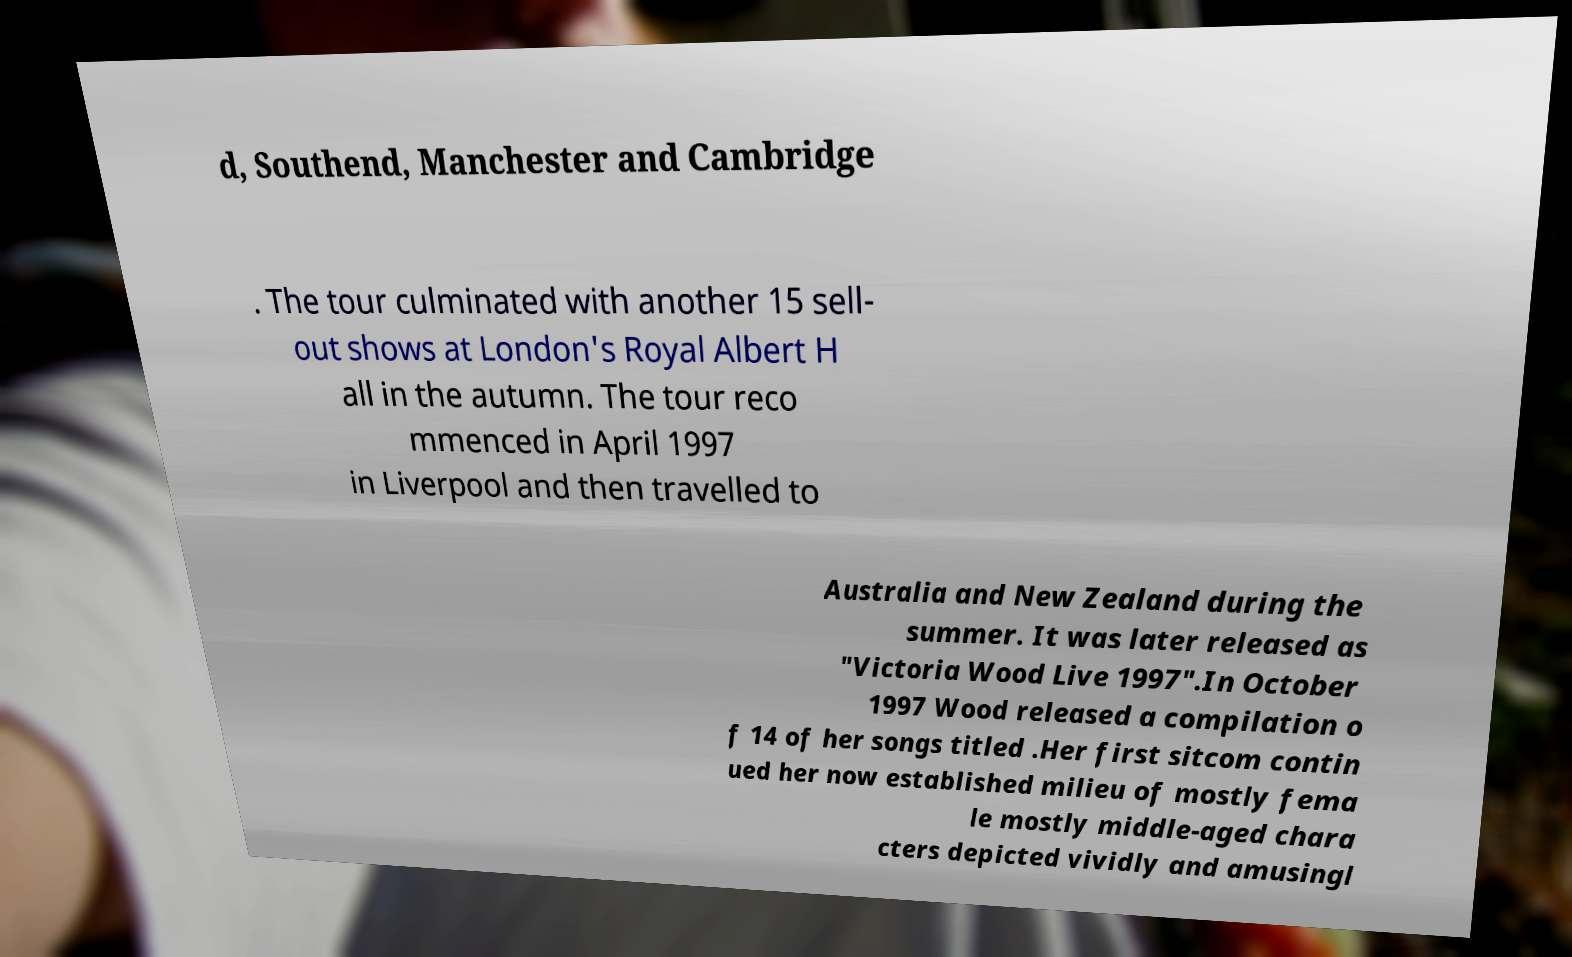Can you read and provide the text displayed in the image?This photo seems to have some interesting text. Can you extract and type it out for me? d, Southend, Manchester and Cambridge . The tour culminated with another 15 sell- out shows at London's Royal Albert H all in the autumn. The tour reco mmenced in April 1997 in Liverpool and then travelled to Australia and New Zealand during the summer. It was later released as "Victoria Wood Live 1997".In October 1997 Wood released a compilation o f 14 of her songs titled .Her first sitcom contin ued her now established milieu of mostly fema le mostly middle-aged chara cters depicted vividly and amusingl 